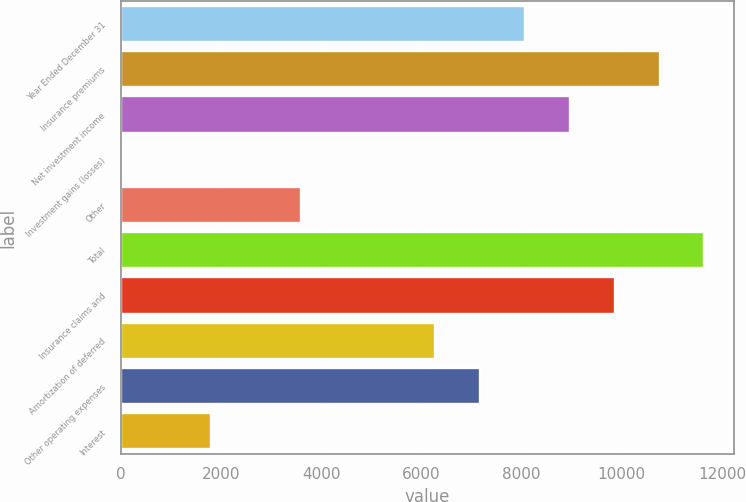Convert chart. <chart><loc_0><loc_0><loc_500><loc_500><bar_chart><fcel>Year Ended December 31<fcel>Insurance premiums<fcel>Net investment income<fcel>Investment gains (losses)<fcel>Other<fcel>Total<fcel>Insurance claims and<fcel>Amortization of deferred<fcel>Other operating expenses<fcel>Interest<nl><fcel>8068.6<fcel>10751.8<fcel>8963<fcel>19<fcel>3596.6<fcel>11646.2<fcel>9857.4<fcel>6279.8<fcel>7174.2<fcel>1807.8<nl></chart> 